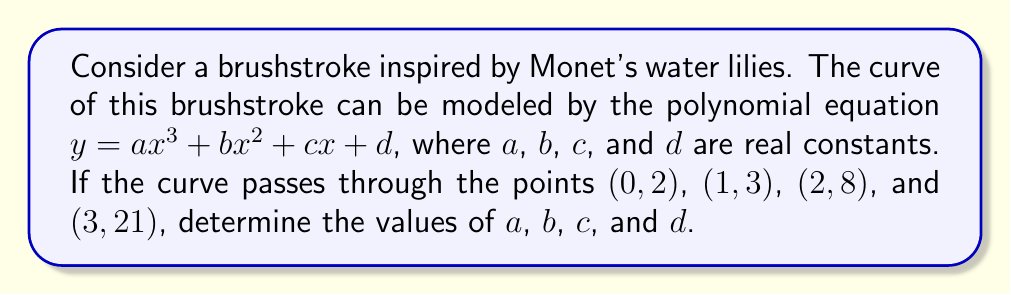Can you solve this math problem? To solve this problem, we'll follow these steps:

1) We have four points that the curve passes through. Let's substitute these points into the general equation:

   For $(0,2)$: $2 = a(0)^3 + b(0)^2 + c(0) + d = d$
   For $(1,3)$: $3 = a(1)^3 + b(1)^2 + c(1) + d = a + b + c + d$
   For $(2,8)$: $8 = a(2)^3 + b(2)^2 + c(2) + d = 8a + 4b + 2c + d$
   For $(3,21)$: $21 = a(3)^3 + b(3)^2 + c(3) + d = 27a + 9b + 3c + d$

2) From the first equation, we can immediately conclude that $d = 2$.

3) Now we have a system of three equations with three unknowns:

   $a + b + c = 1$
   $8a + 4b + 2c = 6$
   $27a + 9b + 3c = 19$

4) Multiply the first equation by 2 and subtract from the second:
   $6a + 2b = 4$

5) Multiply the first equation by 3 and subtract from the third:
   $24a + 6b = 16$

6) Multiply equation from step 4 by 3 and subtract from equation in step 5:
   $6a = 4$
   $a = \frac{2}{3}$

7) Substitute this value of $a$ back into the equation from step 4:
   $4 + 2b = 4$
   $b = 0$

8) Finally, substitute $a$ and $b$ into the first equation from step 3:
   $\frac{2}{3} + 0 + c = 1$
   $c = \frac{1}{3}$

Therefore, we have found all the constants: $a = \frac{2}{3}$, $b = 0$, $c = \frac{1}{3}$, and $d = 2$.
Answer: $a = \frac{2}{3}$, $b = 0$, $c = \frac{1}{3}$, $d = 2$ 